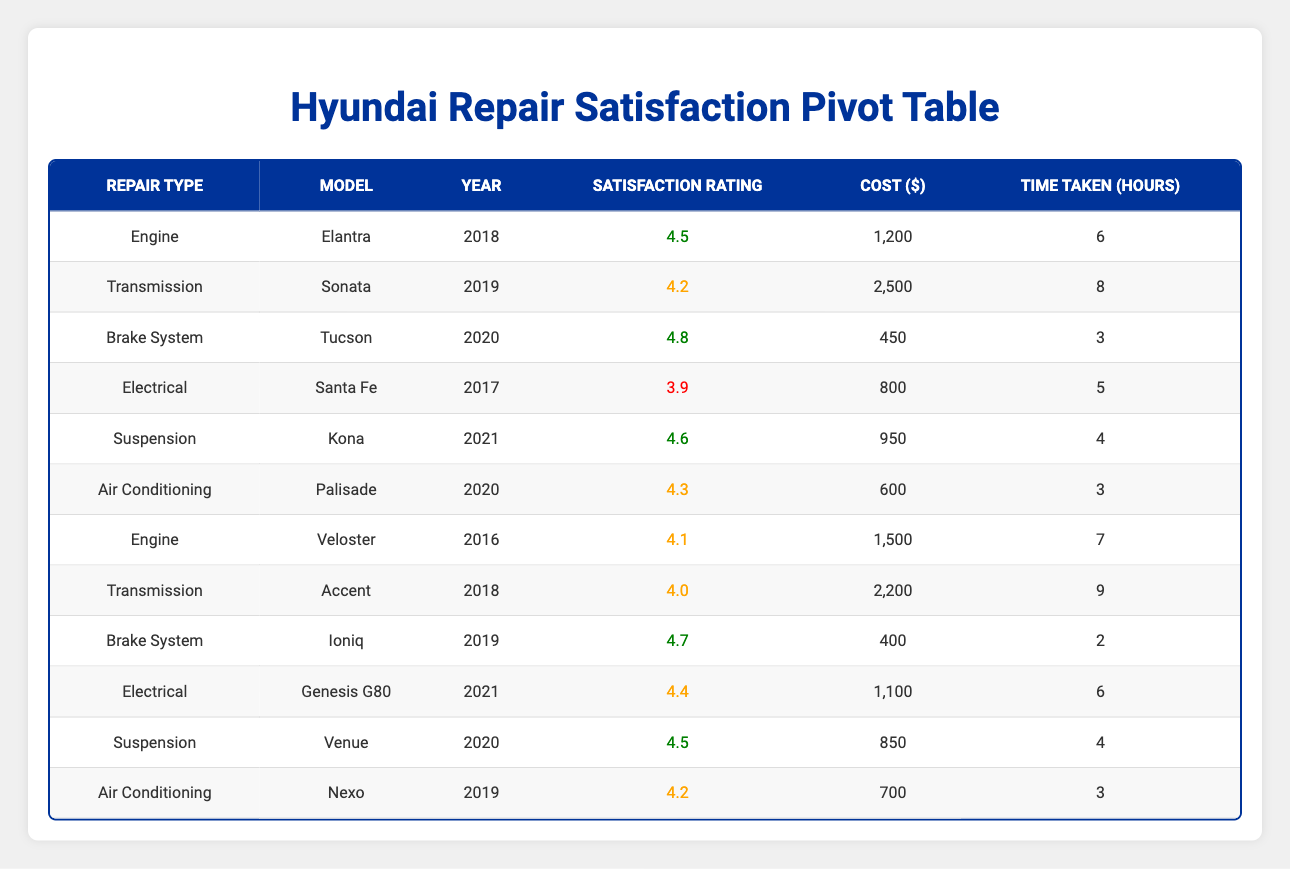What is the satisfaction rating for the Brake System repairs on the Ioniq? The table lists the satisfaction ratings for various repair types, and for the Ioniq, which has a repair type of Brake System, the satisfaction rating is shown to be 4.7.
Answer: 4.7 What was the cost of the Suspension repair for the Kona? In the table, the Kona, which belongs to the Suspension repair type, has a listed repair cost of 950.
Answer: 950 Is the satisfaction rating for the Electrical repair on the Santa Fe above 4.0? The satisfaction rating for the Electrical repair on the Santa Fe is 3.9 according to the table, which is below 4.0. Therefore, the answer is no.
Answer: No Which repair type shows the highest satisfaction rating among the listed models? By reviewing the satisfaction ratings in the table, the highest rating is 4.8 for the Brake System repair of the Tucson.
Answer: 4.8 What is the average satisfaction rating for Engine repairs? There are two Engine repair entries: Elantra with a rating of 4.5 and Veloster with a rating of 4.1. Summing these ratings gives 4.5 + 4.1 = 8.6. There are 2 entries, so the average satisfaction rating is 8.6 / 2 = 4.3.
Answer: 4.3 Does the Sonata have the highest cost for repairs compared to other models? The Sonata's repair cost is 2500, and checking the costs for all repairs shows that this is indeed the highest amount listed in the table, thus the answer is yes.
Answer: Yes What is the difference in satisfaction ratings between the highest rating repair type and the lowest? The highest rating is 4.8 (Brake System, Tucson) and the lowest is 3.9 (Electrical, Santa Fe). The difference is 4.8 - 3.9 = 0.9.
Answer: 0.9 Which model had the lowest satisfaction rating for Electrical repairs, and what was that rating? The Santa Fe is the only listed model for Electrical repairs and has a satisfaction rating of 3.9, thus it is both the lowest rated and the only entry.
Answer: Santa Fe, 3.9 What is the total cost of all Air Conditioning repairs? The table shows two Air Conditioning entries: Palisade costing 600 and Nexo costing 700. Summing these gives 600 + 700 = 1300.
Answer: 1300 